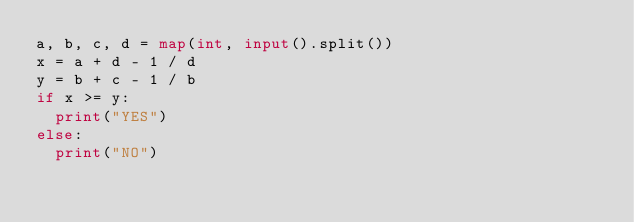<code> <loc_0><loc_0><loc_500><loc_500><_Python_>a, b, c, d = map(int, input().split())
x = a + d - 1 / d
y = b + c - 1 / b
if x >= y:
  print("YES")
else:
  print("NO") </code> 